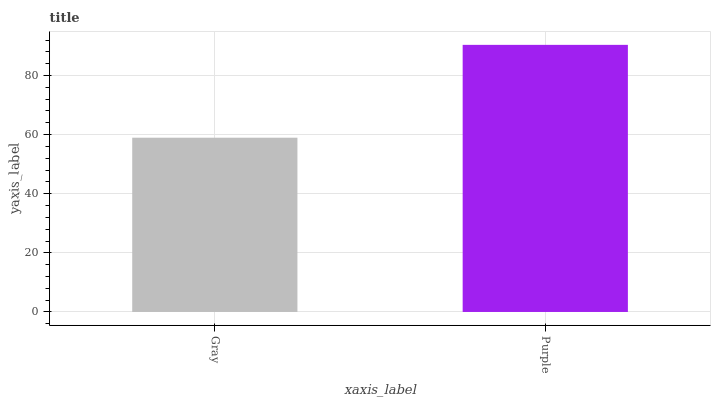Is Gray the minimum?
Answer yes or no. Yes. Is Purple the maximum?
Answer yes or no. Yes. Is Purple the minimum?
Answer yes or no. No. Is Purple greater than Gray?
Answer yes or no. Yes. Is Gray less than Purple?
Answer yes or no. Yes. Is Gray greater than Purple?
Answer yes or no. No. Is Purple less than Gray?
Answer yes or no. No. Is Purple the high median?
Answer yes or no. Yes. Is Gray the low median?
Answer yes or no. Yes. Is Gray the high median?
Answer yes or no. No. Is Purple the low median?
Answer yes or no. No. 